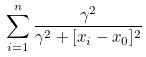<formula> <loc_0><loc_0><loc_500><loc_500>\sum _ { i = 1 } ^ { n } \frac { \gamma ^ { 2 } } { \gamma ^ { 2 } + [ x _ { i } - x _ { 0 } ] ^ { 2 } }</formula> 